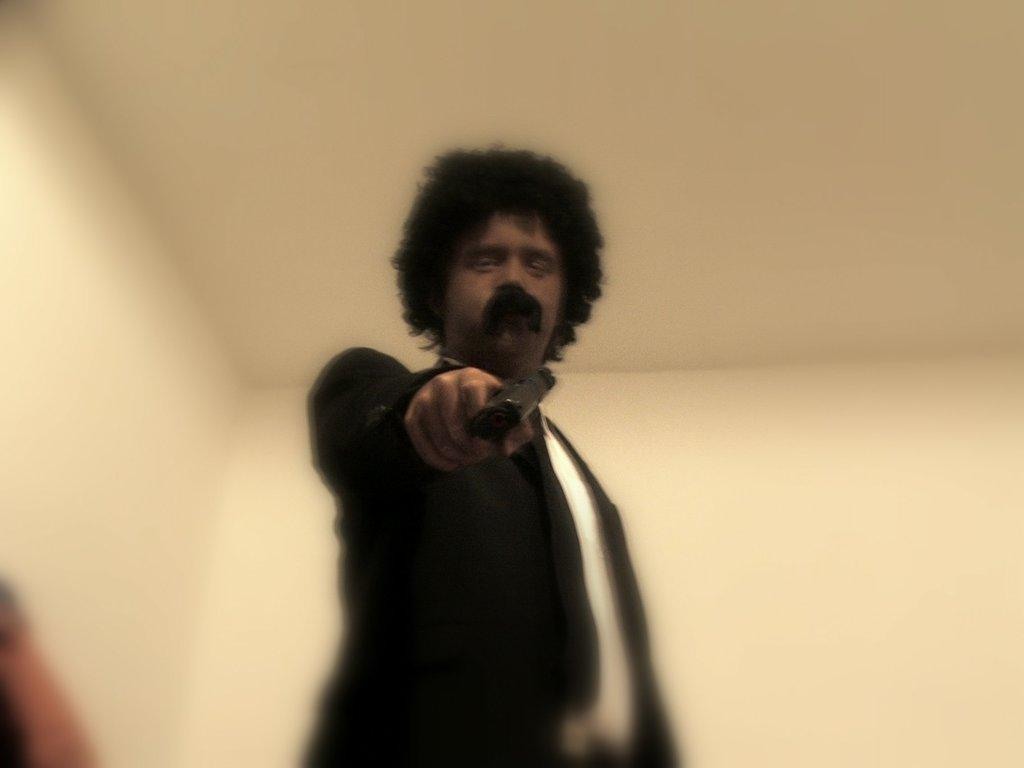What is the main subject of the image? There is a person in the image. What is the person wearing? The person is wearing a black suit. What is the person holding in their hand? The person is holding a gun with one hand. What is the person's posture in the image? The person is standing. What can be seen in the background of the image? There is a ceiling and a wall in the background of the image. What type of yam is the person holding in the image? There is no yam present in the image; the person is holding a gun. Is the person wearing a hat in the image? The provided facts do not mention a hat, so we cannot determine if the person is wearing one. 